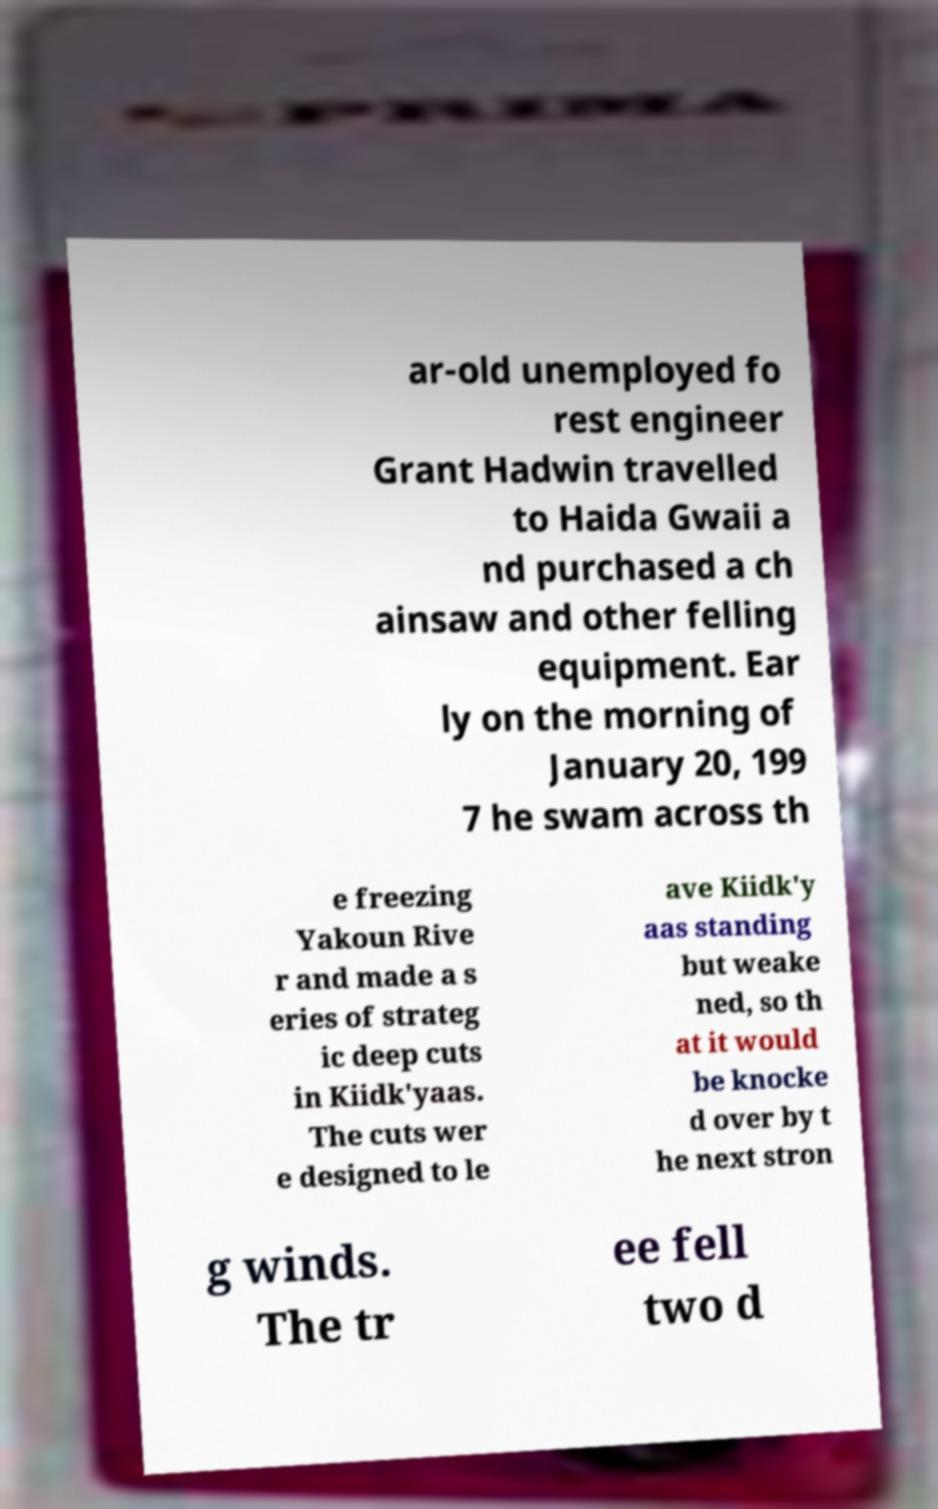There's text embedded in this image that I need extracted. Can you transcribe it verbatim? ar-old unemployed fo rest engineer Grant Hadwin travelled to Haida Gwaii a nd purchased a ch ainsaw and other felling equipment. Ear ly on the morning of January 20, 199 7 he swam across th e freezing Yakoun Rive r and made a s eries of strateg ic deep cuts in Kiidk'yaas. The cuts wer e designed to le ave Kiidk'y aas standing but weake ned, so th at it would be knocke d over by t he next stron g winds. The tr ee fell two d 